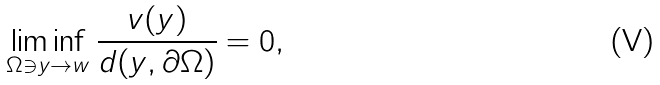Convert formula to latex. <formula><loc_0><loc_0><loc_500><loc_500>\liminf _ { \Omega \ni y \to w } \frac { v ( y ) } { d ( y , \partial \Omega ) } = 0 ,</formula> 